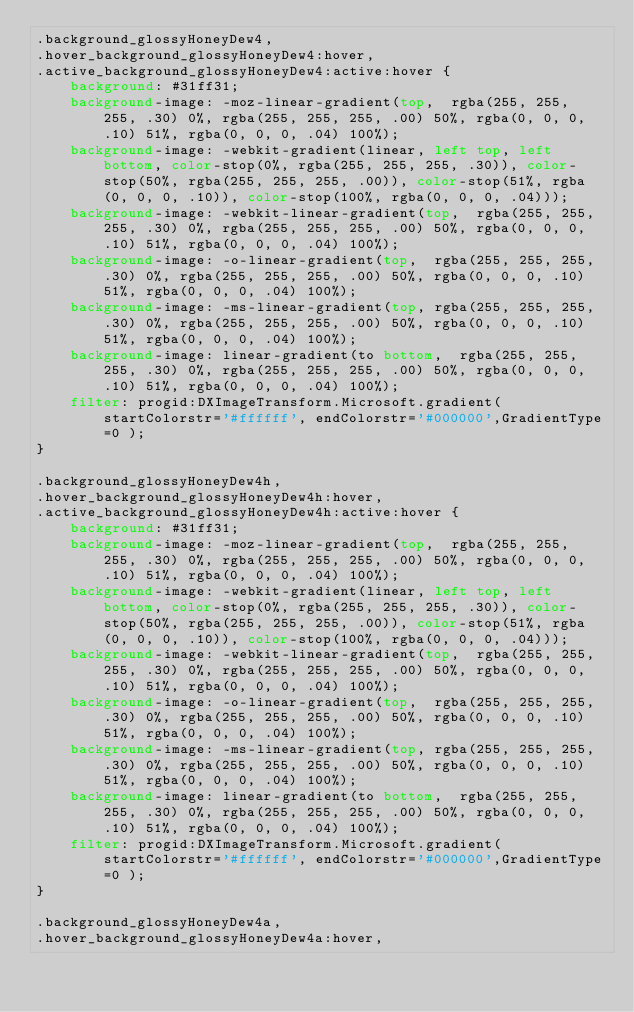Convert code to text. <code><loc_0><loc_0><loc_500><loc_500><_CSS_>.background_glossyHoneyDew4,
.hover_background_glossyHoneyDew4:hover,
.active_background_glossyHoneyDew4:active:hover {
    background: #31ff31;
    background-image: -moz-linear-gradient(top,  rgba(255, 255, 255, .30) 0%, rgba(255, 255, 255, .00) 50%, rgba(0, 0, 0, .10) 51%, rgba(0, 0, 0, .04) 100%);
    background-image: -webkit-gradient(linear, left top, left bottom, color-stop(0%, rgba(255, 255, 255, .30)), color-stop(50%, rgba(255, 255, 255, .00)), color-stop(51%, rgba(0, 0, 0, .10)), color-stop(100%, rgba(0, 0, 0, .04)));
    background-image: -webkit-linear-gradient(top,  rgba(255, 255, 255, .30) 0%, rgba(255, 255, 255, .00) 50%, rgba(0, 0, 0, .10) 51%, rgba(0, 0, 0, .04) 100%);
    background-image: -o-linear-gradient(top,  rgba(255, 255, 255, .30) 0%, rgba(255, 255, 255, .00) 50%, rgba(0, 0, 0, .10) 51%, rgba(0, 0, 0, .04) 100%);
    background-image: -ms-linear-gradient(top, rgba(255, 255, 255, .30) 0%, rgba(255, 255, 255, .00) 50%, rgba(0, 0, 0, .10) 51%, rgba(0, 0, 0, .04) 100%);
    background-image: linear-gradient(to bottom,  rgba(255, 255, 255, .30) 0%, rgba(255, 255, 255, .00) 50%, rgba(0, 0, 0, .10) 51%, rgba(0, 0, 0, .04) 100%);
    filter: progid:DXImageTransform.Microsoft.gradient( startColorstr='#ffffff', endColorstr='#000000',GradientType=0 );
}

.background_glossyHoneyDew4h,
.hover_background_glossyHoneyDew4h:hover,
.active_background_glossyHoneyDew4h:active:hover {
    background: #31ff31;
    background-image: -moz-linear-gradient(top,  rgba(255, 255, 255, .30) 0%, rgba(255, 255, 255, .00) 50%, rgba(0, 0, 0, .10) 51%, rgba(0, 0, 0, .04) 100%);
    background-image: -webkit-gradient(linear, left top, left bottom, color-stop(0%, rgba(255, 255, 255, .30)), color-stop(50%, rgba(255, 255, 255, .00)), color-stop(51%, rgba(0, 0, 0, .10)), color-stop(100%, rgba(0, 0, 0, .04)));
    background-image: -webkit-linear-gradient(top,  rgba(255, 255, 255, .30) 0%, rgba(255, 255, 255, .00) 50%, rgba(0, 0, 0, .10) 51%, rgba(0, 0, 0, .04) 100%);
    background-image: -o-linear-gradient(top,  rgba(255, 255, 255, .30) 0%, rgba(255, 255, 255, .00) 50%, rgba(0, 0, 0, .10) 51%, rgba(0, 0, 0, .04) 100%);
    background-image: -ms-linear-gradient(top, rgba(255, 255, 255, .30) 0%, rgba(255, 255, 255, .00) 50%, rgba(0, 0, 0, .10) 51%, rgba(0, 0, 0, .04) 100%);
    background-image: linear-gradient(to bottom,  rgba(255, 255, 255, .30) 0%, rgba(255, 255, 255, .00) 50%, rgba(0, 0, 0, .10) 51%, rgba(0, 0, 0, .04) 100%);
    filter: progid:DXImageTransform.Microsoft.gradient( startColorstr='#ffffff', endColorstr='#000000',GradientType=0 );
}

.background_glossyHoneyDew4a,
.hover_background_glossyHoneyDew4a:hover,</code> 